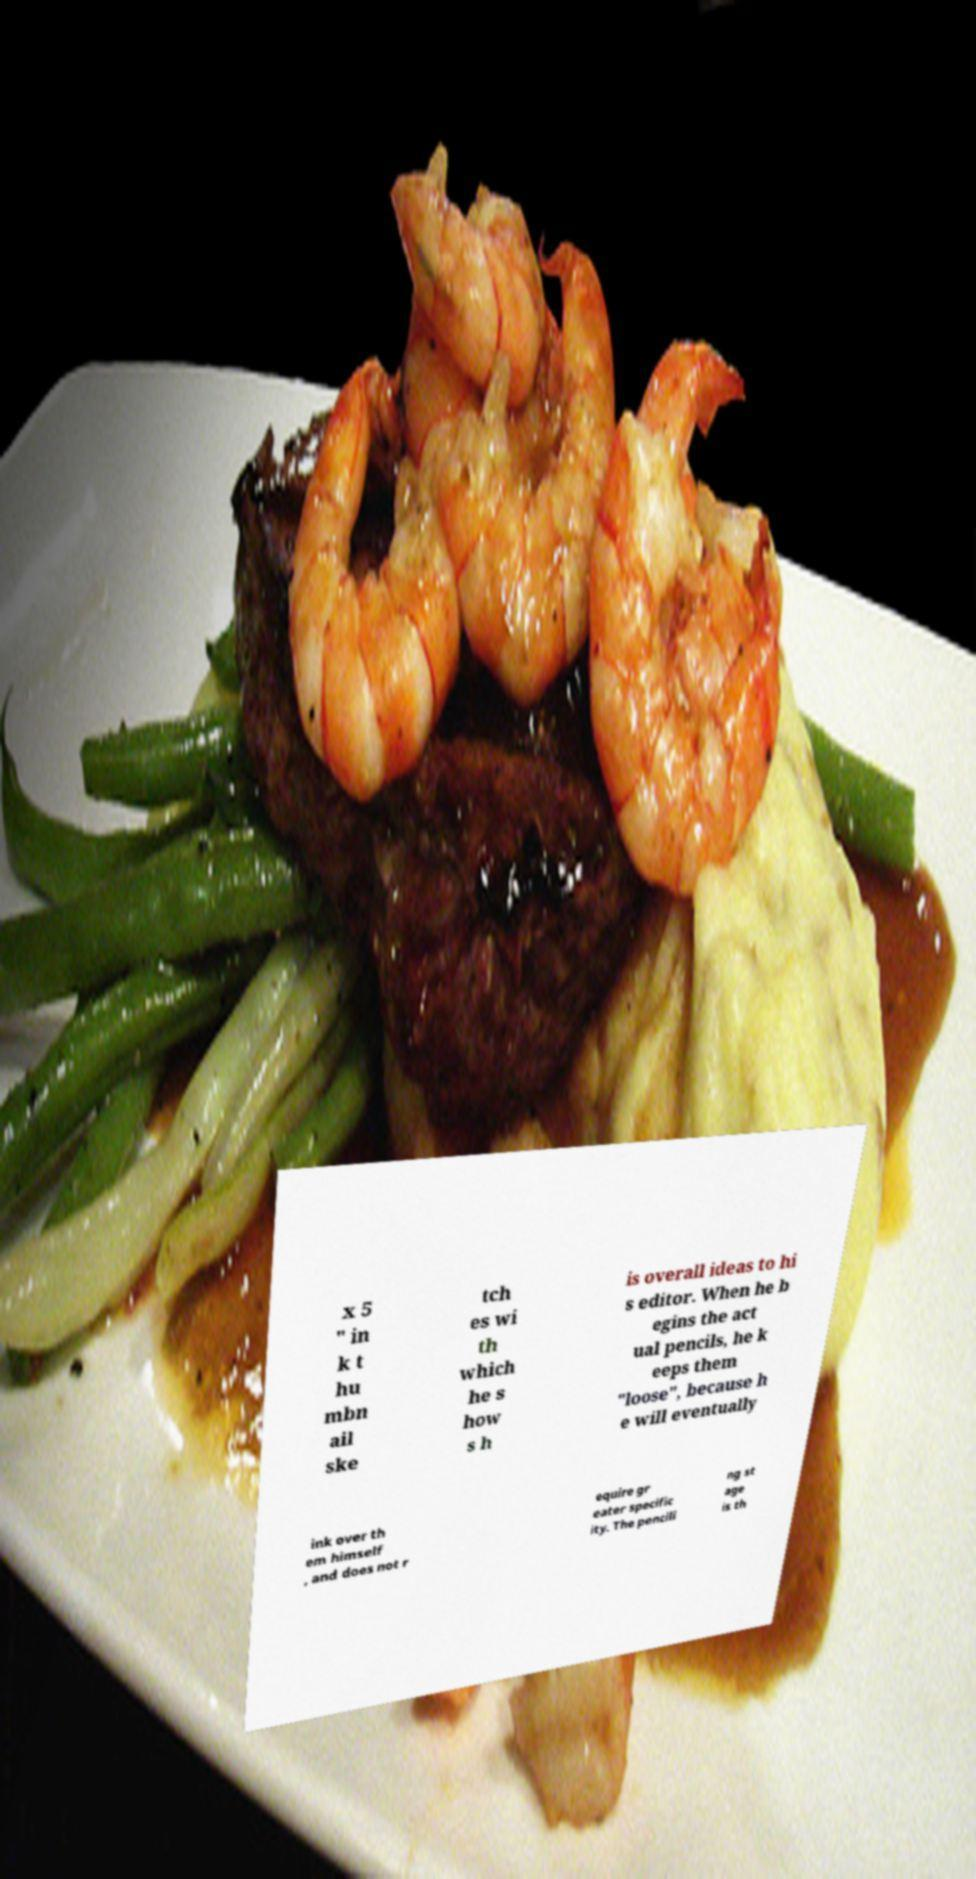Could you assist in decoding the text presented in this image and type it out clearly? x 5 " in k t hu mbn ail ske tch es wi th which he s how s h is overall ideas to hi s editor. When he b egins the act ual pencils, he k eeps them "loose", because h e will eventually ink over th em himself , and does not r equire gr eater specific ity. The pencili ng st age is th 